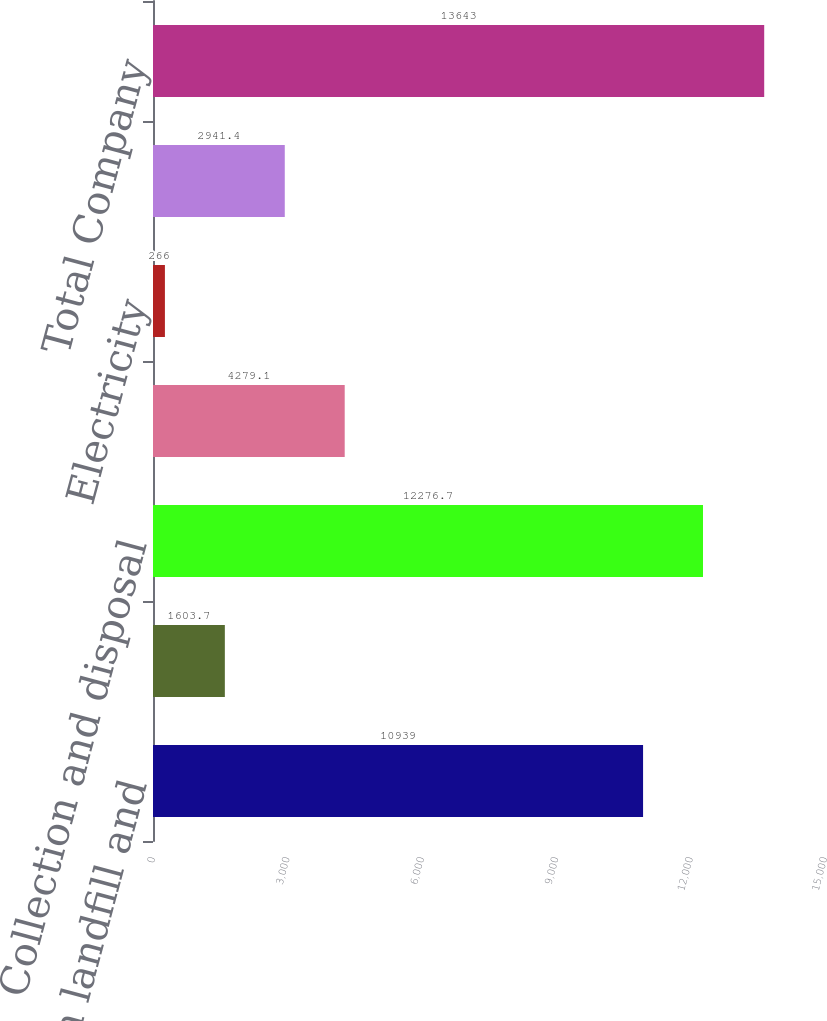<chart> <loc_0><loc_0><loc_500><loc_500><bar_chart><fcel>Collection landfill and<fcel>Waste-to-energy disposal<fcel>Collection and disposal<fcel>Recycling commodities<fcel>Electricity<fcel>Fuel surcharges and mandated<fcel>Total Company<nl><fcel>10939<fcel>1603.7<fcel>12276.7<fcel>4279.1<fcel>266<fcel>2941.4<fcel>13643<nl></chart> 